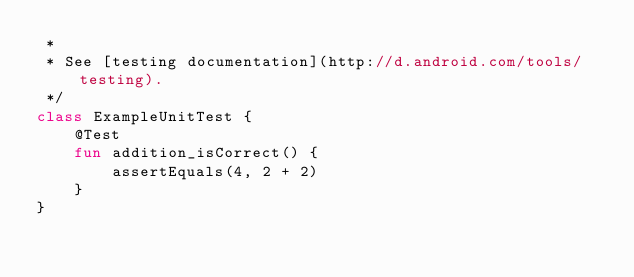<code> <loc_0><loc_0><loc_500><loc_500><_Kotlin_> *
 * See [testing documentation](http://d.android.com/tools/testing).
 */
class ExampleUnitTest {
    @Test
    fun addition_isCorrect() {
        assertEquals(4, 2 + 2)
    }
}</code> 